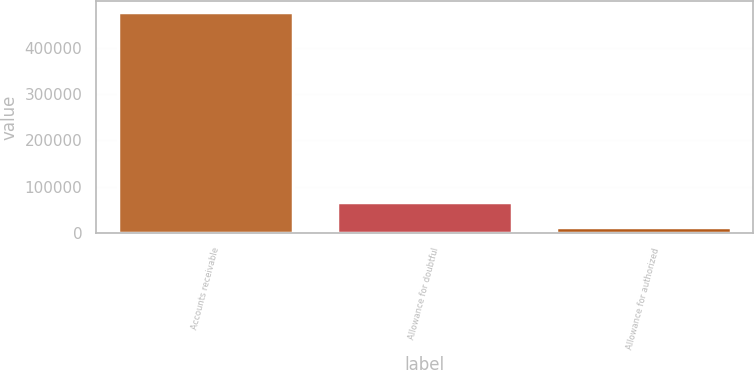Convert chart to OTSL. <chart><loc_0><loc_0><loc_500><loc_500><bar_chart><fcel>Accounts receivable<fcel>Allowance for doubtful<fcel>Allowance for authorized<nl><fcel>476060<fcel>68401<fcel>14464<nl></chart> 